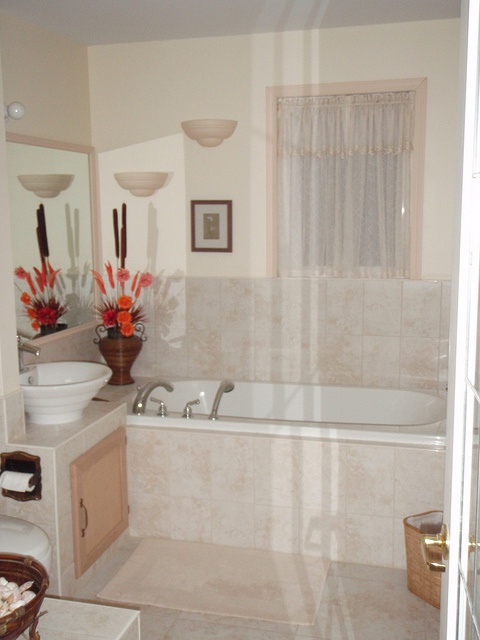Describe the objects in this image and their specific colors. I can see potted plant in gray, maroon, darkgray, and brown tones, sink in gray, darkgray, and lightgray tones, vase in gray, maroon, and black tones, and toilet in gray, darkgray, and lightgray tones in this image. 